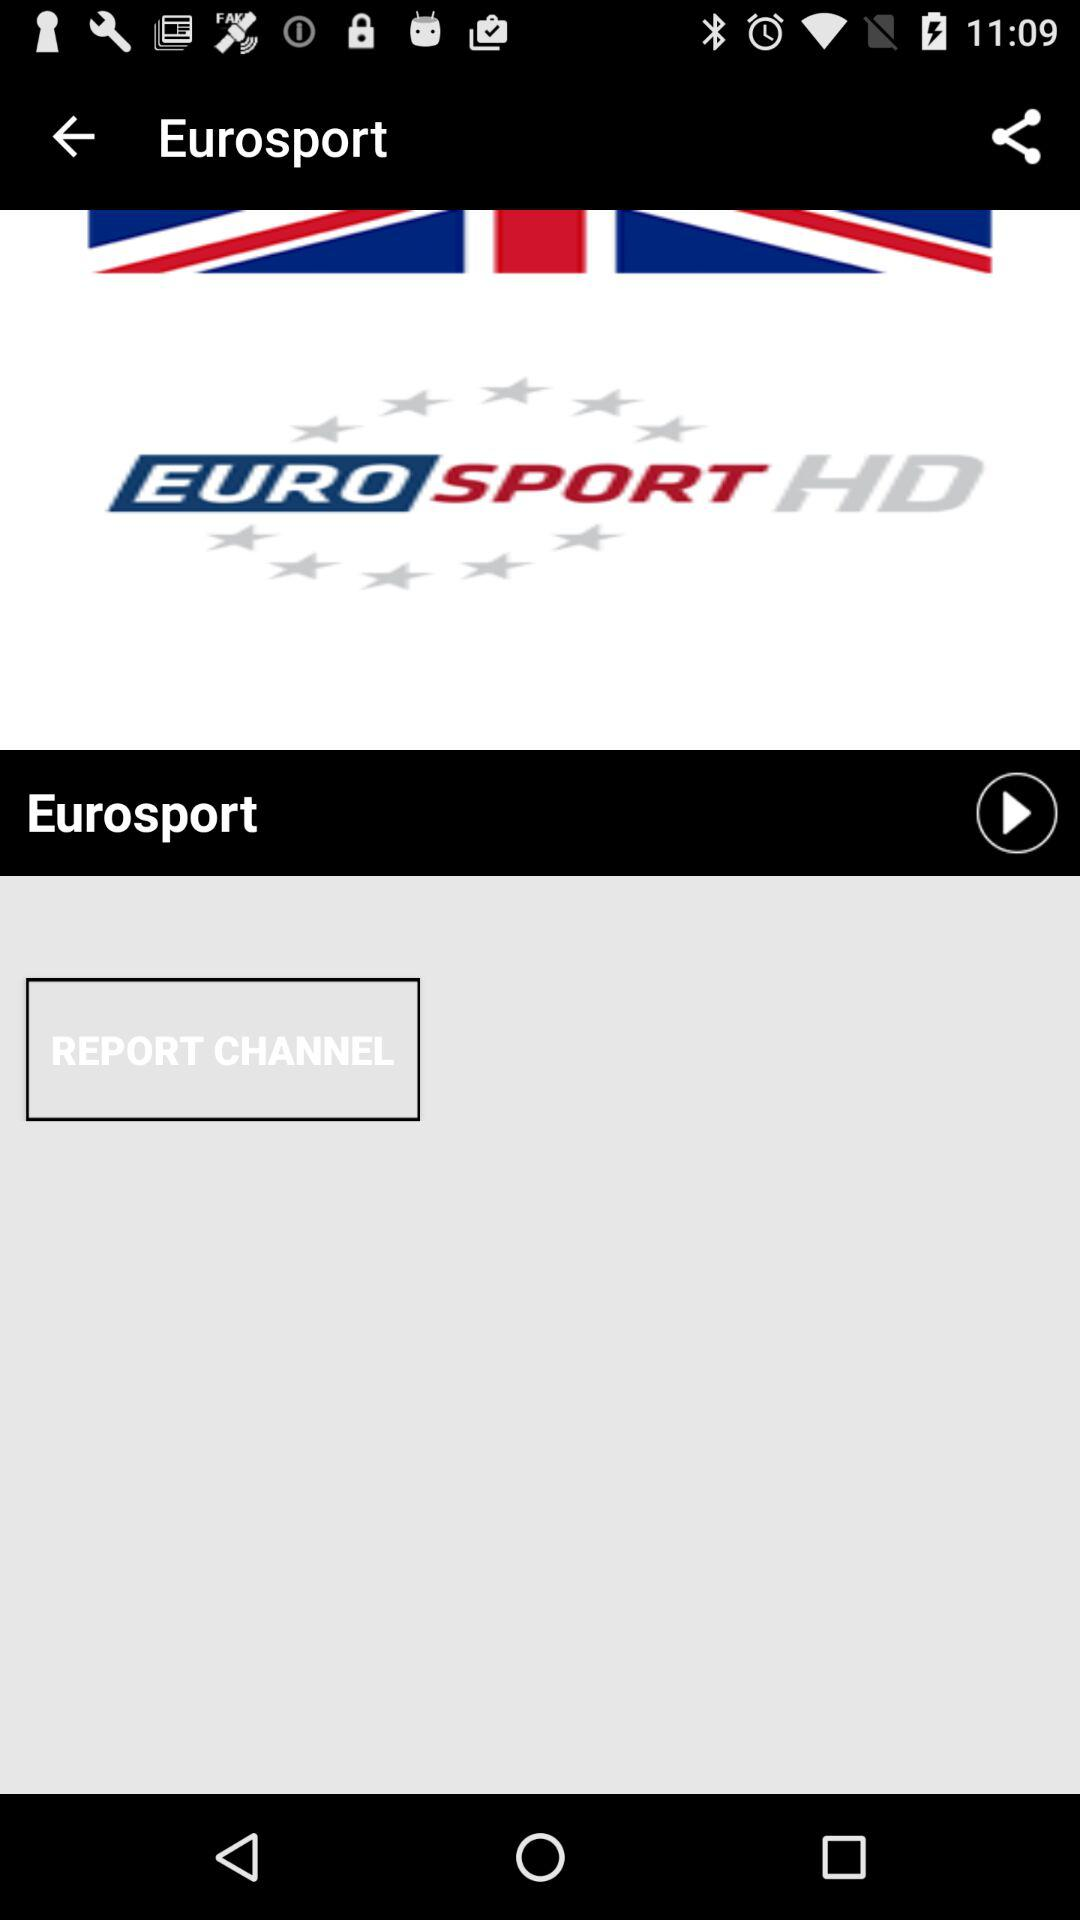What is the channel name? The channel name is "Eurosport". 